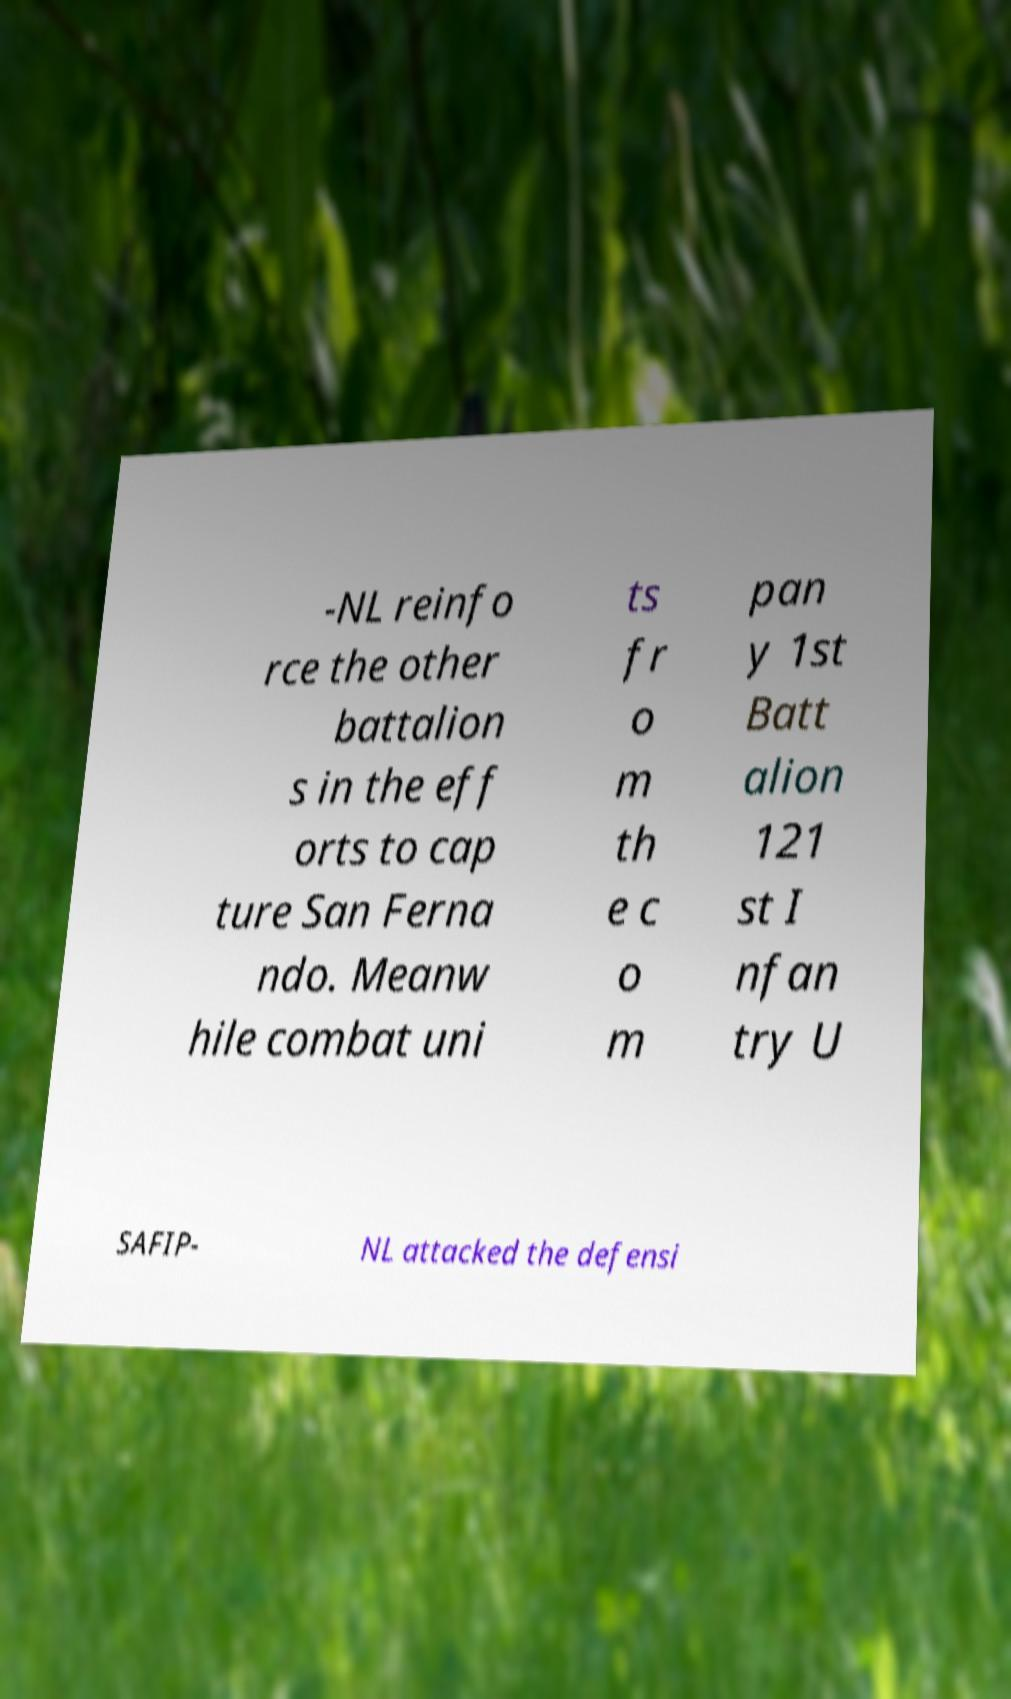Can you accurately transcribe the text from the provided image for me? -NL reinfo rce the other battalion s in the eff orts to cap ture San Ferna ndo. Meanw hile combat uni ts fr o m th e c o m pan y 1st Batt alion 121 st I nfan try U SAFIP- NL attacked the defensi 